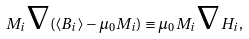Convert formula to latex. <formula><loc_0><loc_0><loc_500><loc_500>M _ { i } { \boldsymbol \nabla } ( \langle B _ { i } \rangle - \mu _ { 0 } M _ { i } ) \equiv \mu _ { 0 } M _ { i } { \boldsymbol \nabla } H _ { i } ,</formula> 